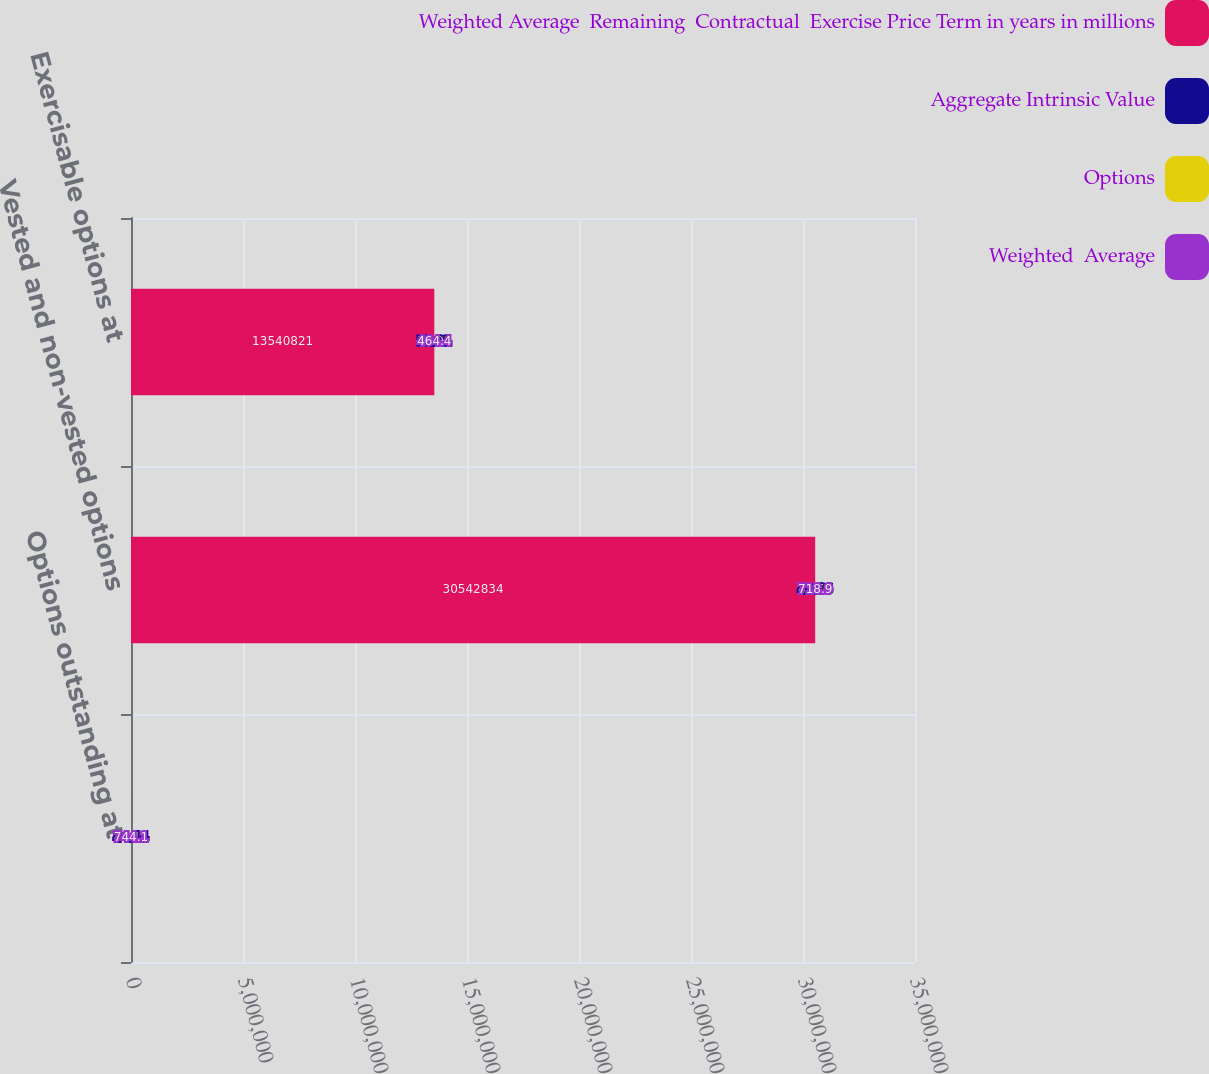Convert chart. <chart><loc_0><loc_0><loc_500><loc_500><stacked_bar_chart><ecel><fcel>Options outstanding at<fcel>Vested and non-vested options<fcel>Exercisable options at<nl><fcel>Weighted Average  Remaining  Contractual  Exercise Price Term in years in millions<fcel>44.14<fcel>3.05428e+07<fcel>1.35408e+07<nl><fcel>Aggregate Intrinsic Value<fcel>44.14<fcel>43.66<fcel>32.91<nl><fcel>Options<fcel>7.03<fcel>6.96<fcel>5.37<nl><fcel>Weighted  Average<fcel>744.1<fcel>718.9<fcel>464.4<nl></chart> 